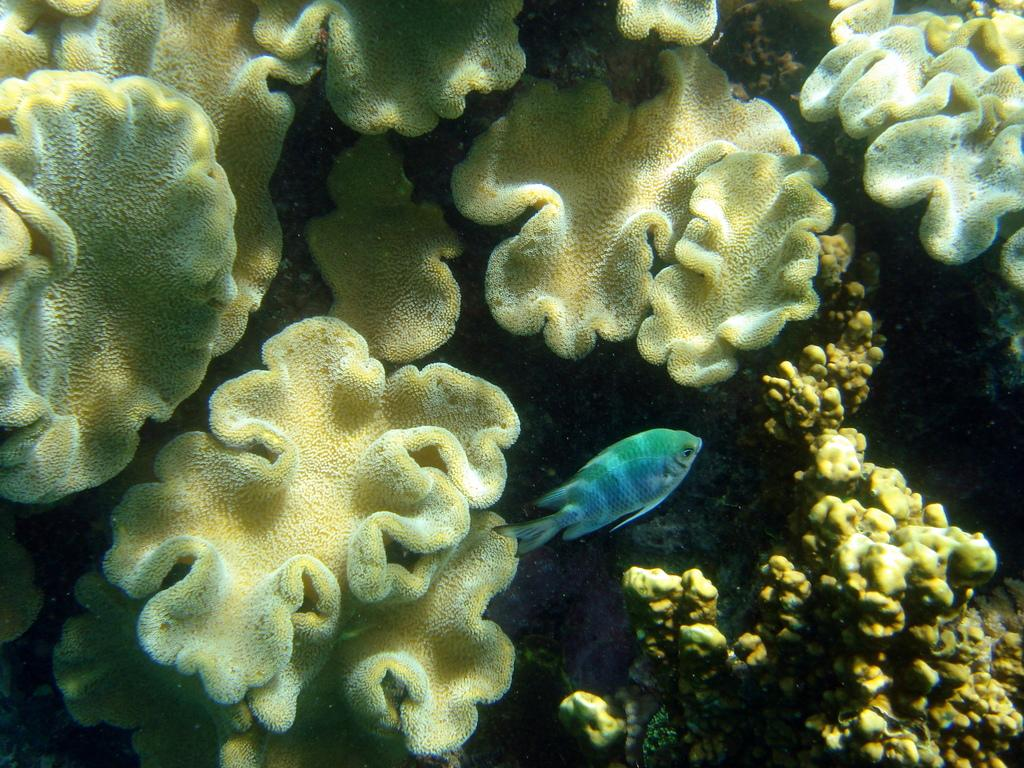What type of animal is present in the image? There is a fish in the image. What other elements can be seen in the image besides the fish? There are wild plants in the image. What type of ball is being used in the class depicted in the image? There is no class or ball present in the image; it features a fish and wild plants. Does the existence of the fish in the image prove the existence of a parallel universe? The presence of a fish in the image does not provide any information about the existence of a parallel universe. 